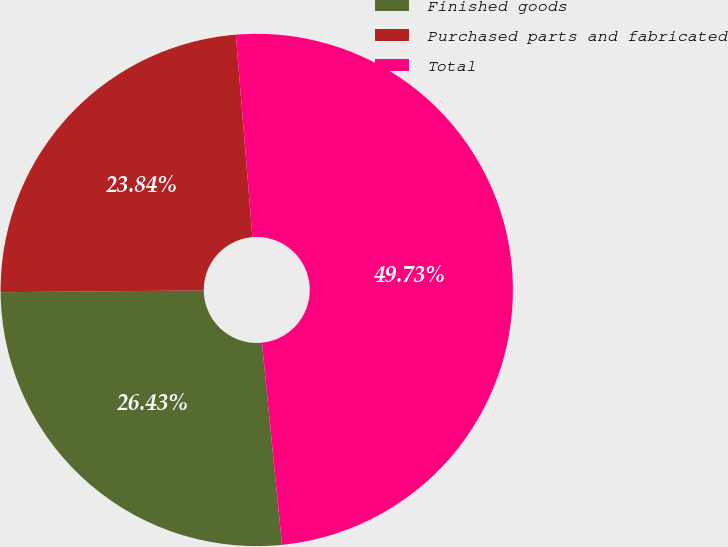<chart> <loc_0><loc_0><loc_500><loc_500><pie_chart><fcel>Finished goods<fcel>Purchased parts and fabricated<fcel>Total<nl><fcel>26.43%<fcel>23.84%<fcel>49.73%<nl></chart> 